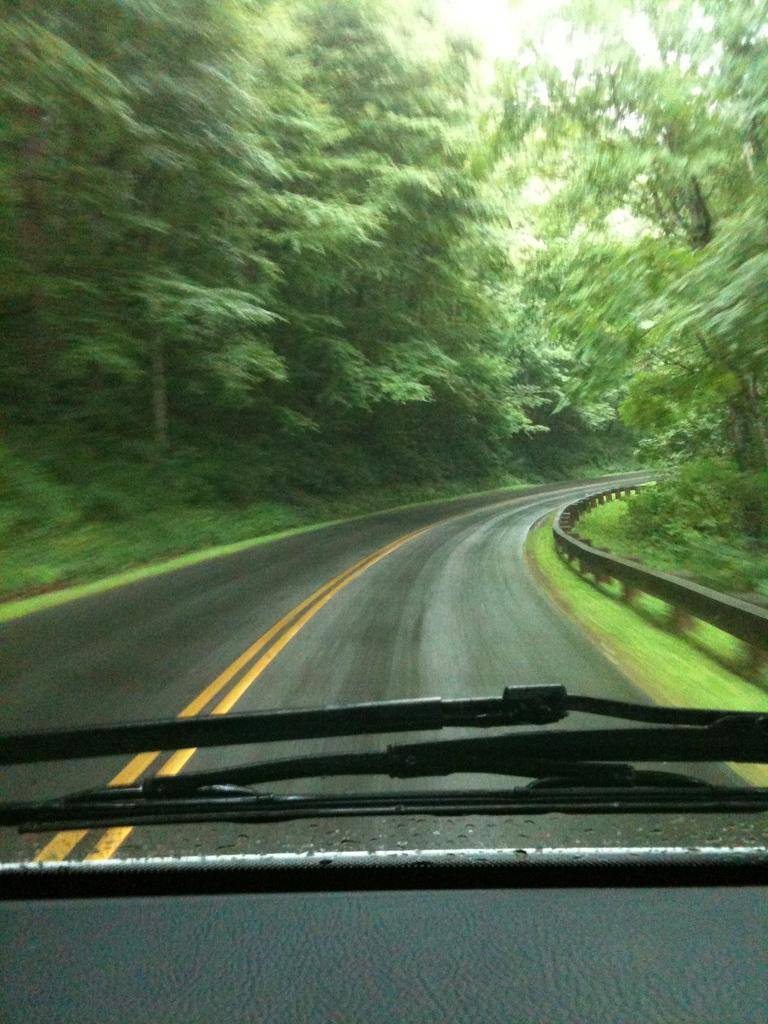What objects are present in the image that are used for cleaning or clearing? There are wipers in the image. What type of surface can be seen in the image? There is a road visible in the image. What type of vegetation is present in the image? There are trees in the image. Can you tell me how many rings the stranger is wearing in the image? There is no stranger present in the image, and therefore no rings to count. What type of bead is visible hanging from the trees in the image? There is no bead present in the image; it only features wipers, a road, and trees. 